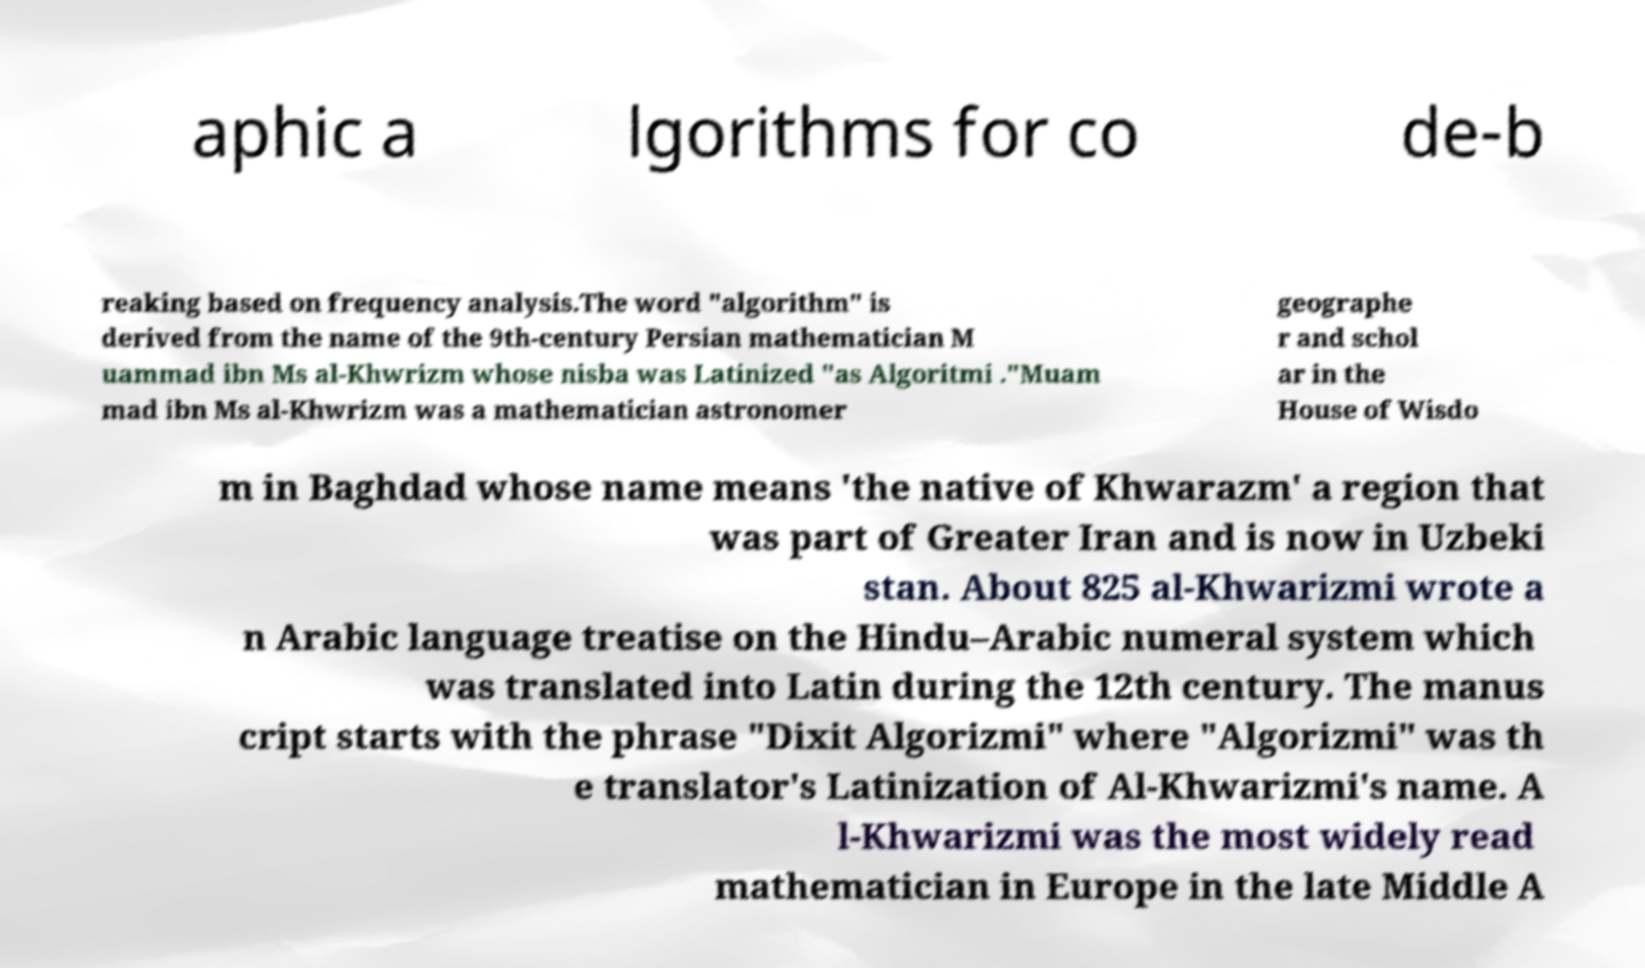There's text embedded in this image that I need extracted. Can you transcribe it verbatim? aphic a lgorithms for co de-b reaking based on frequency analysis.The word "algorithm" is derived from the name of the 9th-century Persian mathematician M uammad ibn Ms al-Khwrizm whose nisba was Latinized "as Algoritmi ."Muam mad ibn Ms al-Khwrizm was a mathematician astronomer geographe r and schol ar in the House of Wisdo m in Baghdad whose name means 'the native of Khwarazm' a region that was part of Greater Iran and is now in Uzbeki stan. About 825 al-Khwarizmi wrote a n Arabic language treatise on the Hindu–Arabic numeral system which was translated into Latin during the 12th century. The manus cript starts with the phrase "Dixit Algorizmi" where "Algorizmi" was th e translator's Latinization of Al-Khwarizmi's name. A l-Khwarizmi was the most widely read mathematician in Europe in the late Middle A 